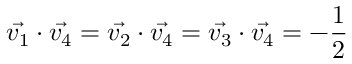Convert formula to latex. <formula><loc_0><loc_0><loc_500><loc_500>\vec { v _ { 1 } } \cdot \vec { v _ { 4 } } = \vec { v _ { 2 } } \cdot \vec { v _ { 4 } } = \vec { v _ { 3 } } \cdot \vec { v _ { 4 } } = - \frac { 1 } { 2 }</formula> 